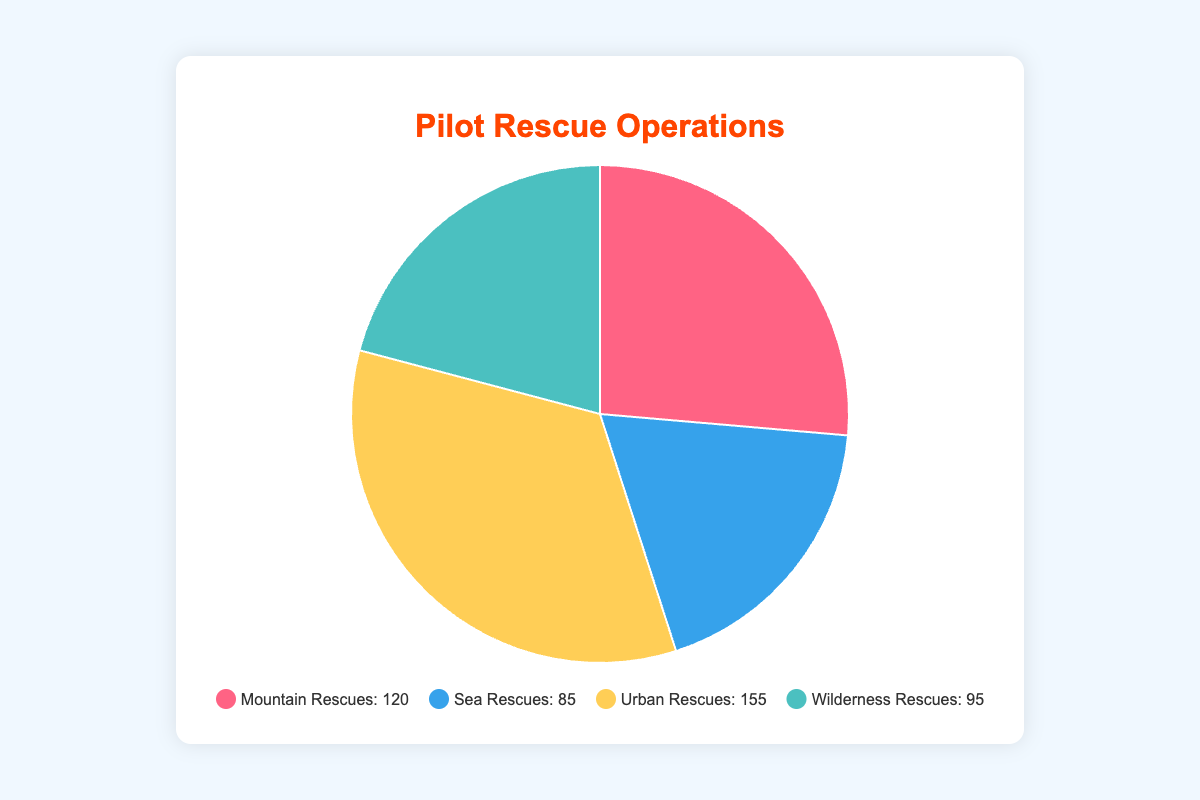Which rescue operation has the highest number of operations? By looking at the pie chart, the sector with the largest proportion represents the category with the highest number of operations, which is labeled as Urban Rescues with 155 operations.
Answer: Urban Rescues What percentage of total operations do Wilderness Rescues represent? Calculate the total number of operations: 120 (Mountain Rescues) + 85 (Sea Rescues) + 155 (Urban Rescues) + 95 (Wilderness Rescues) = 455. Then, (95/455) * 100% = approximately 20.88%.
Answer: 20.88% How many more Urban Rescues are there compared to Sea Rescues? Subtract the number of Sea Rescues from Urban Rescues: 155 (Urban Rescues) - 85 (Sea Rescues) = 70.
Answer: 70 Which rescue operations are represented by blue and yellow colors in the pie chart? The pie chart legend matches the colors and labels with the operations. According to the legend, blue represents Sea Rescues and yellow represents Urban Rescues.
Answer: Sea Rescues (blue) and Urban Rescues (yellow) What is the total number of Mountain and Wilderness Rescues combined? Add the number of Mountain Rescues and Wilderness Rescues: 120 (Mountain Rescues) + 95 (Wilderness Rescues) = 215.
Answer: 215 Is the total number of Sea and Mountain Rescues more or less than the total number of Urban Rescues? Add the number of Sea Rescues and Mountain Rescues: 85 (Sea Rescues) + 120 (Mountain Rescues) = 205. Compare this to Urban Rescues, which is 155. Since 205 > 155, it is more.
Answer: More If Wilderness Rescues increased by 10%, how many operations would that be? Calculate 10% of 95, which is 9.5. Add this to the original Wilderness Rescues: 95 + 9.5 = 104.5. Since the number of operations should be a whole number, this means approximately 105.
Answer: 105 What is the difference in the number of operations between Mountain Rescues and Wilderness Rescues? Subtract the number of Wilderness Rescues from Mountain Rescues: 120 (Mountain Rescues) - 95 (Wilderness Rescues) = 25.
Answer: 25 